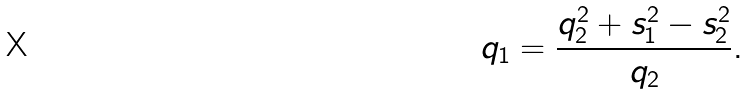Convert formula to latex. <formula><loc_0><loc_0><loc_500><loc_500>q _ { 1 } = \frac { q _ { 2 } ^ { 2 } + s _ { 1 } ^ { 2 } - s _ { 2 } ^ { 2 } } { q _ { 2 } } .</formula> 